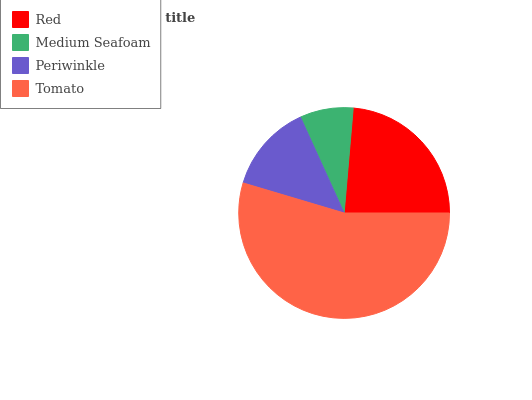Is Medium Seafoam the minimum?
Answer yes or no. Yes. Is Tomato the maximum?
Answer yes or no. Yes. Is Periwinkle the minimum?
Answer yes or no. No. Is Periwinkle the maximum?
Answer yes or no. No. Is Periwinkle greater than Medium Seafoam?
Answer yes or no. Yes. Is Medium Seafoam less than Periwinkle?
Answer yes or no. Yes. Is Medium Seafoam greater than Periwinkle?
Answer yes or no. No. Is Periwinkle less than Medium Seafoam?
Answer yes or no. No. Is Red the high median?
Answer yes or no. Yes. Is Periwinkle the low median?
Answer yes or no. Yes. Is Tomato the high median?
Answer yes or no. No. Is Tomato the low median?
Answer yes or no. No. 